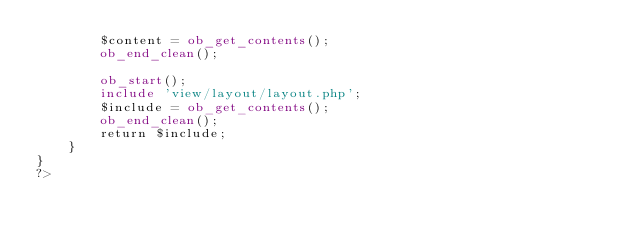<code> <loc_0><loc_0><loc_500><loc_500><_PHP_>		$content = ob_get_contents();
		ob_end_clean();
		
		ob_start();
		include 'view/layout/layout.php';
		$include = ob_get_contents();
		ob_end_clean();
		return $include;
	}
}
?></code> 